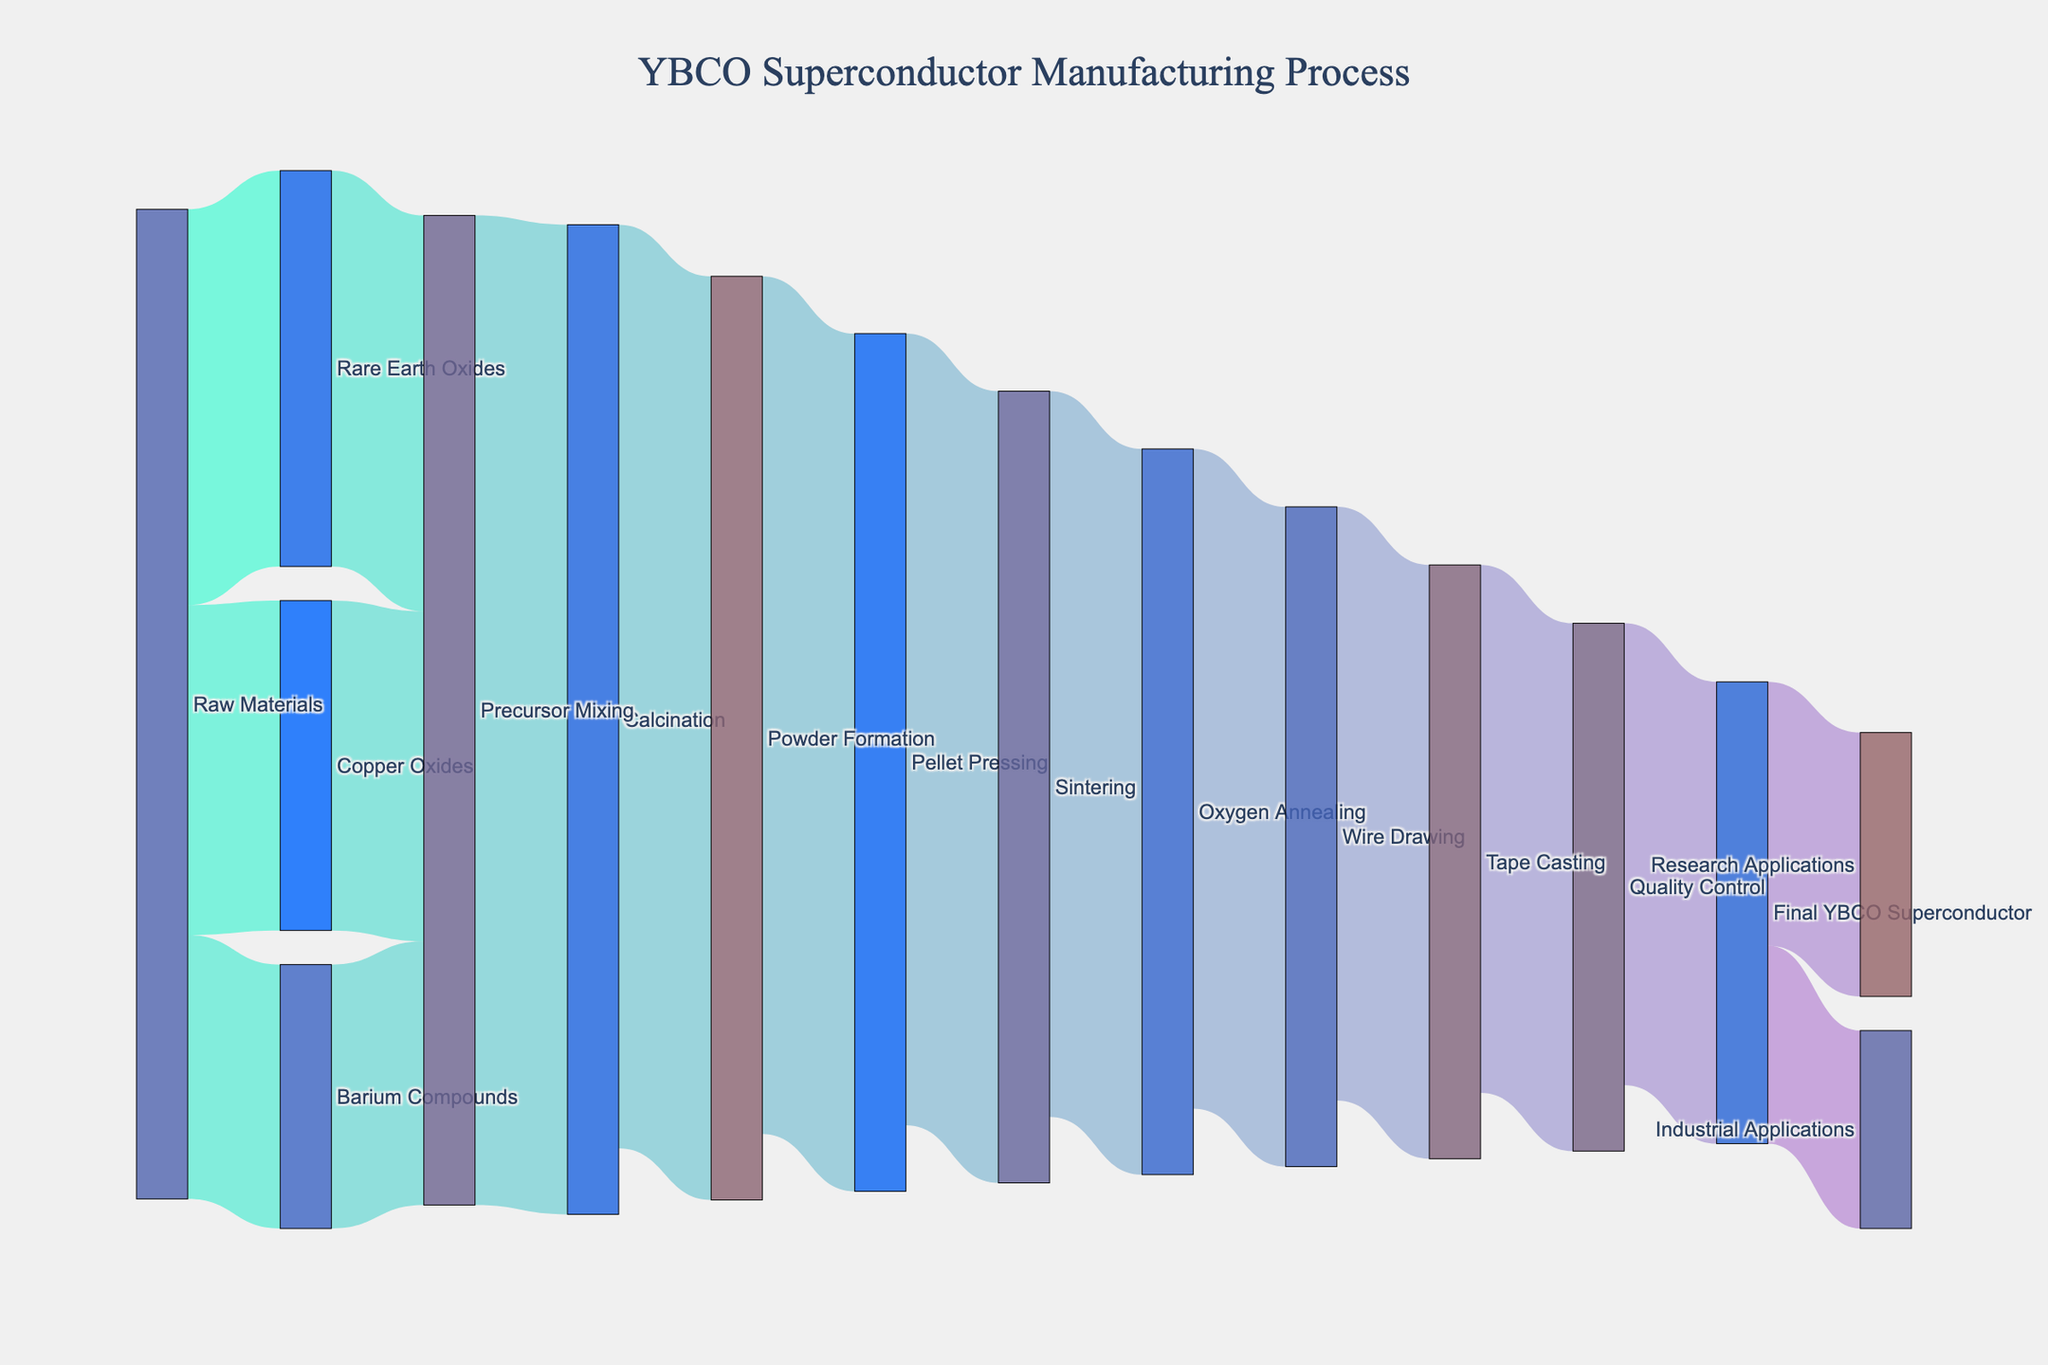What's the title of the Sankey diagram? The title is usually displayed at the top of the diagram. In this case, it is “YBCO Superconductor Manufacturing Process”.
Answer: YBCO Superconductor Manufacturing Process How many processing stages are shown between Raw Materials and the Final YBCO Superconductor? To find this, count the number of unique stages the materials go through from Raw Materials to Final YBCO Superconductor.
Answer: 8 stages What is the initial value of Rare Earth Oxides in the manufacturing process? Look for the Rare Earth Oxides node and identify the incoming flow from Raw Materials, which is labeled with a number.
Answer: 30 Which material has the lowest initial input value among Raw Materials, Rare Earth Oxides, Copper Oxides, and Barium Compounds? Compare the values of Rare Earth Oxides (30), Copper Oxides (25), and Barium Compounds (20) coming from Raw Materials.
Answer: Barium Compounds How much material is transferred from Precursor Mixing to Calcination? Identify the flow labeled as Precursor Mixing to Calcination and check the value associated with this movement.
Answer: 75 What is the value of the final YBCO Superconductor used in industrial applications? Find the link leading from the Final YBCO Superconductor to Industrial Applications and read the associated value.
Answer: 15 Calculate the total value of materials entering Precursor Mixing. Add the values from Rare Earth Oxides (30), Copper Oxides (25), and Barium Compounds (20) that enter Precursor Mixing.
Answer: 75 Compare the values from Pellet Pressing to Sintering and Sintering to Oxygen Annealing. Which one is greater? Verify both flows; Pellet Pressing to Sintering is 60, and Sintering to Oxygen Annealing is 55. Compare the two values.
Answer: Pellet Pressing to Sintering What stage follows Oxygen Annealing in the manufacturing process? Identify the node that Oxygen Annealing flows into, which is clearly labeled.
Answer: Wire Drawing How much material is lost through the stages from Precursor Mixing to Final YBCO Superconductor? Calculate the initial material input into Precursor Mixing (75), then subtract the output value at each stage until reaching Final YBCO Superconductor (35). This would be: 75 (Precursor Mixing) - [75 - 70 (Calcination)] - [70 - 65 (Powder Formation)] - [65 - 60 (Pellet Pressing)] - [60 - 55 (Sintering)] - [55 - 50 (Oxygen Annealing)] - [50 - 45 (Wire Drawing)] - [45 - 40 (Tape Casting)] - [40 - 35 (Quality Control)] = 40 loss
Answer: 40 